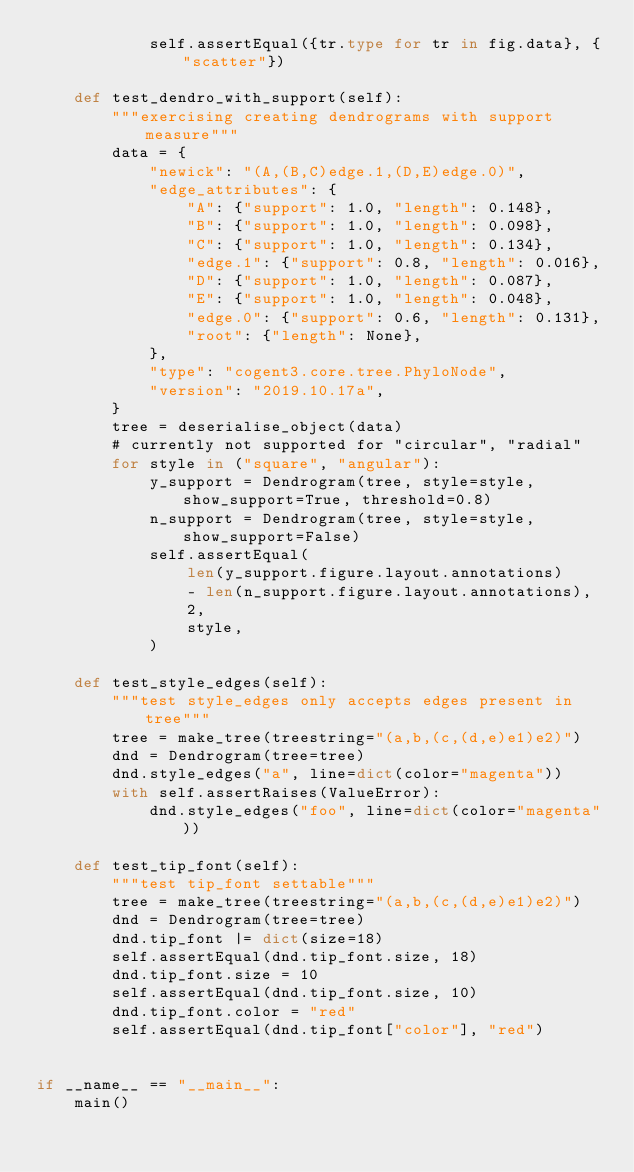<code> <loc_0><loc_0><loc_500><loc_500><_Python_>            self.assertEqual({tr.type for tr in fig.data}, {"scatter"})

    def test_dendro_with_support(self):
        """exercising creating dendrograms with support measure"""
        data = {
            "newick": "(A,(B,C)edge.1,(D,E)edge.0)",
            "edge_attributes": {
                "A": {"support": 1.0, "length": 0.148},
                "B": {"support": 1.0, "length": 0.098},
                "C": {"support": 1.0, "length": 0.134},
                "edge.1": {"support": 0.8, "length": 0.016},
                "D": {"support": 1.0, "length": 0.087},
                "E": {"support": 1.0, "length": 0.048},
                "edge.0": {"support": 0.6, "length": 0.131},
                "root": {"length": None},
            },
            "type": "cogent3.core.tree.PhyloNode",
            "version": "2019.10.17a",
        }
        tree = deserialise_object(data)
        # currently not supported for "circular", "radial"
        for style in ("square", "angular"):
            y_support = Dendrogram(tree, style=style, show_support=True, threshold=0.8)
            n_support = Dendrogram(tree, style=style, show_support=False)
            self.assertEqual(
                len(y_support.figure.layout.annotations)
                - len(n_support.figure.layout.annotations),
                2,
                style,
            )

    def test_style_edges(self):
        """test style_edges only accepts edges present in tree"""
        tree = make_tree(treestring="(a,b,(c,(d,e)e1)e2)")
        dnd = Dendrogram(tree=tree)
        dnd.style_edges("a", line=dict(color="magenta"))
        with self.assertRaises(ValueError):
            dnd.style_edges("foo", line=dict(color="magenta"))

    def test_tip_font(self):
        """test tip_font settable"""
        tree = make_tree(treestring="(a,b,(c,(d,e)e1)e2)")
        dnd = Dendrogram(tree=tree)
        dnd.tip_font |= dict(size=18)
        self.assertEqual(dnd.tip_font.size, 18)
        dnd.tip_font.size = 10
        self.assertEqual(dnd.tip_font.size, 10)
        dnd.tip_font.color = "red"
        self.assertEqual(dnd.tip_font["color"], "red")


if __name__ == "__main__":
    main()
</code> 